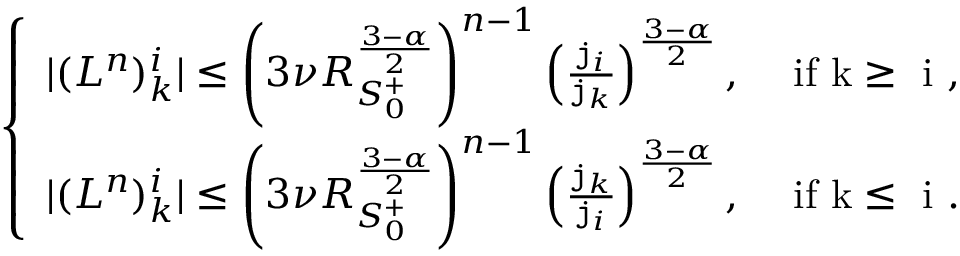<formula> <loc_0><loc_0><loc_500><loc_500>\begin{array} { r } { \left \{ \begin{array} { l l } { | ( { L } ^ { n } ) _ { k } ^ { i } | \leq \left ( 3 \nu R _ { S _ { 0 } ^ { + } } ^ { \frac { 3 - \alpha } { 2 } } \right ) ^ { n - 1 } \left ( \frac { j _ { i } } { j _ { k } } \right ) ^ { \frac { 3 - \alpha } { 2 } } , } & { i f k \geq i , } \\ { | ( { L } ^ { n } ) _ { k } ^ { i } | \leq \left ( 3 \nu R _ { S _ { 0 } ^ { + } } ^ { \frac { 3 - \alpha } { 2 } } \right ) ^ { n - 1 } \left ( \frac { j _ { k } } { j _ { i } } \right ) ^ { \frac { 3 - \alpha } { 2 } } , } & { i f k \leq i . } \end{array} } \end{array}</formula> 